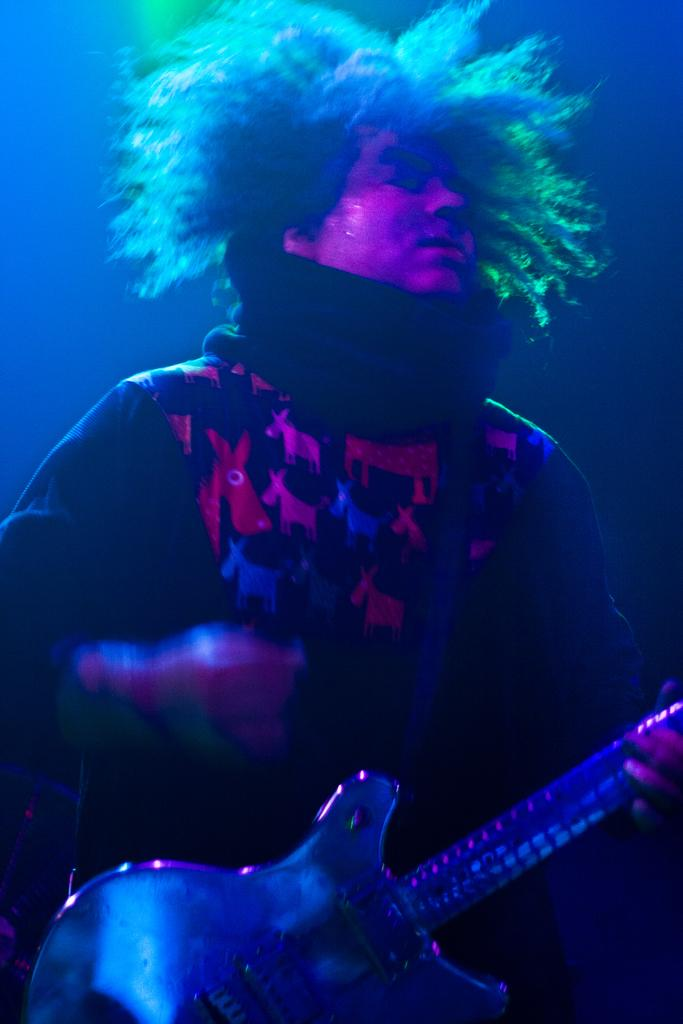What is the main subject of the image? There is a person standing in the image. What is the person doing in the image? The person is playing the guitar. Can you describe the background of the image? The background of the image is dark. What type of thread can be seen in the person's hands while playing the guitar in the image? There is no thread visible in the person's hands or in the image; they are playing the guitar. Can you see a hill in the background of the image? The background of the image is dark, and there is no hill visible. 